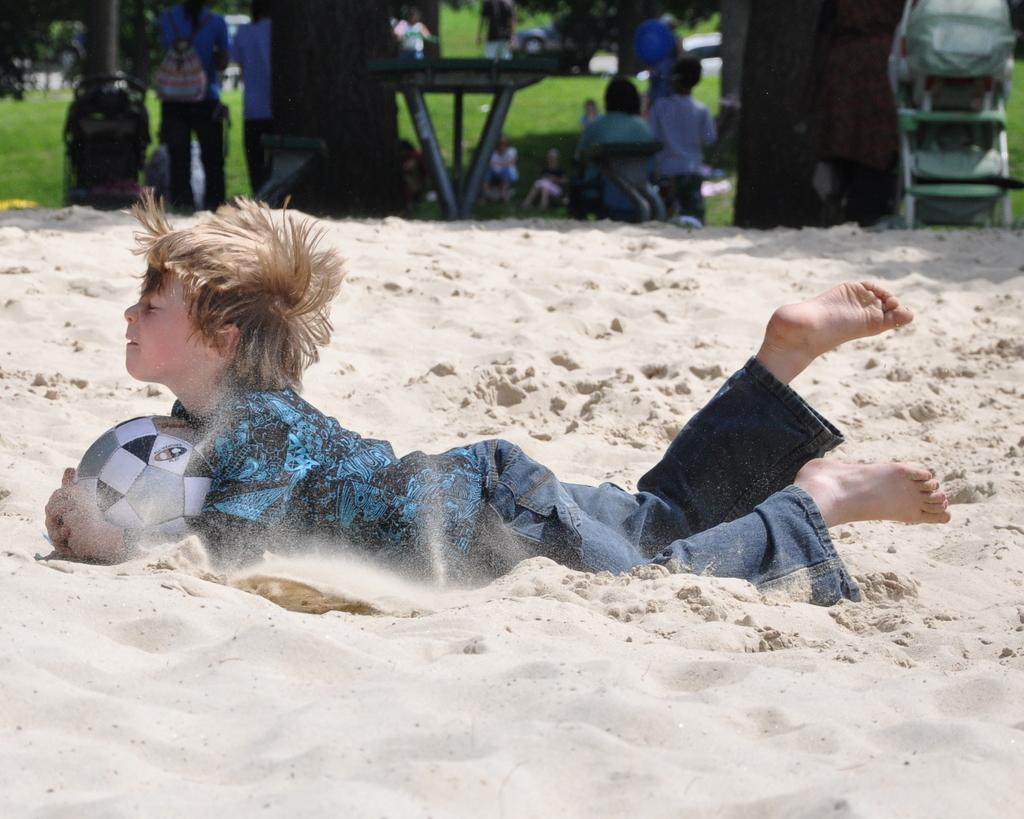Who is the main subject in the image? There is a boy in the image. What is the boy doing in the image? The boy is playing with a ball. Where is the boy located in the image? The boy is on a sandy area. What can be seen in the background of the image? There is a table, people, trees, and a lawn in the background of the image. How many parcels can be seen in the image? There are no parcels present in the image. What type of kite is being flown by the crowd in the image? There is no crowd or kite present in the image. 